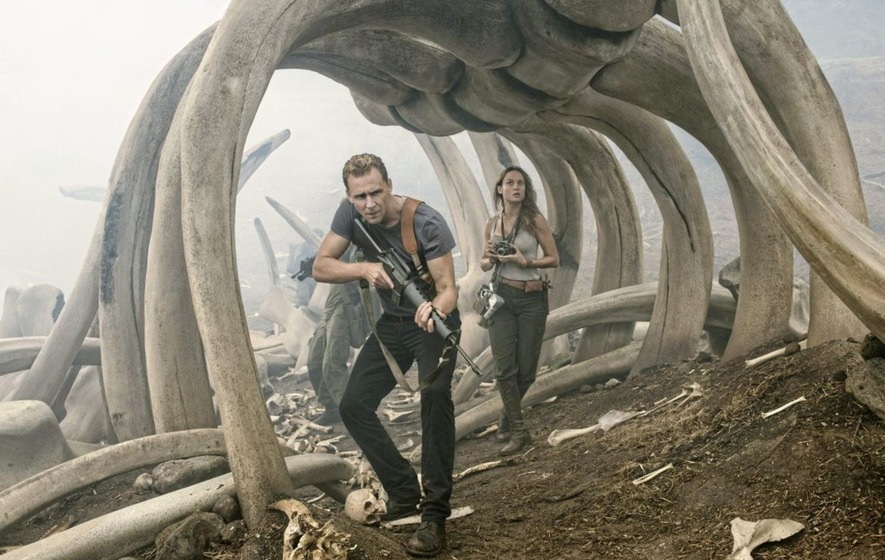Formulate a plausible scenario showing the characters' purpose for being in this location. Captain James Conrad and Mason Weaver were part of a scientific expedition tasked with uncovering the mysteries of the Valley of the Titans. Their mission was to document and study the remains of these ancient creatures. Conrad, with his military background, was there to ensure the safety of the team, while Weaver, a renowned photojournalist, aimed to capture the awe-inspiring sights and raise awareness about the existence of such uncharted lands. Little did they know that their quest for knowledge would lead them into the heart of an ancient and perilous territory, where their survival instincts would be tested at every step. The characters are explorers mapping uncharted territories. Their expedition has led them to the remains of a massive, unknown creature, suggesting they are on the verge of a groundbreaking discovery. 